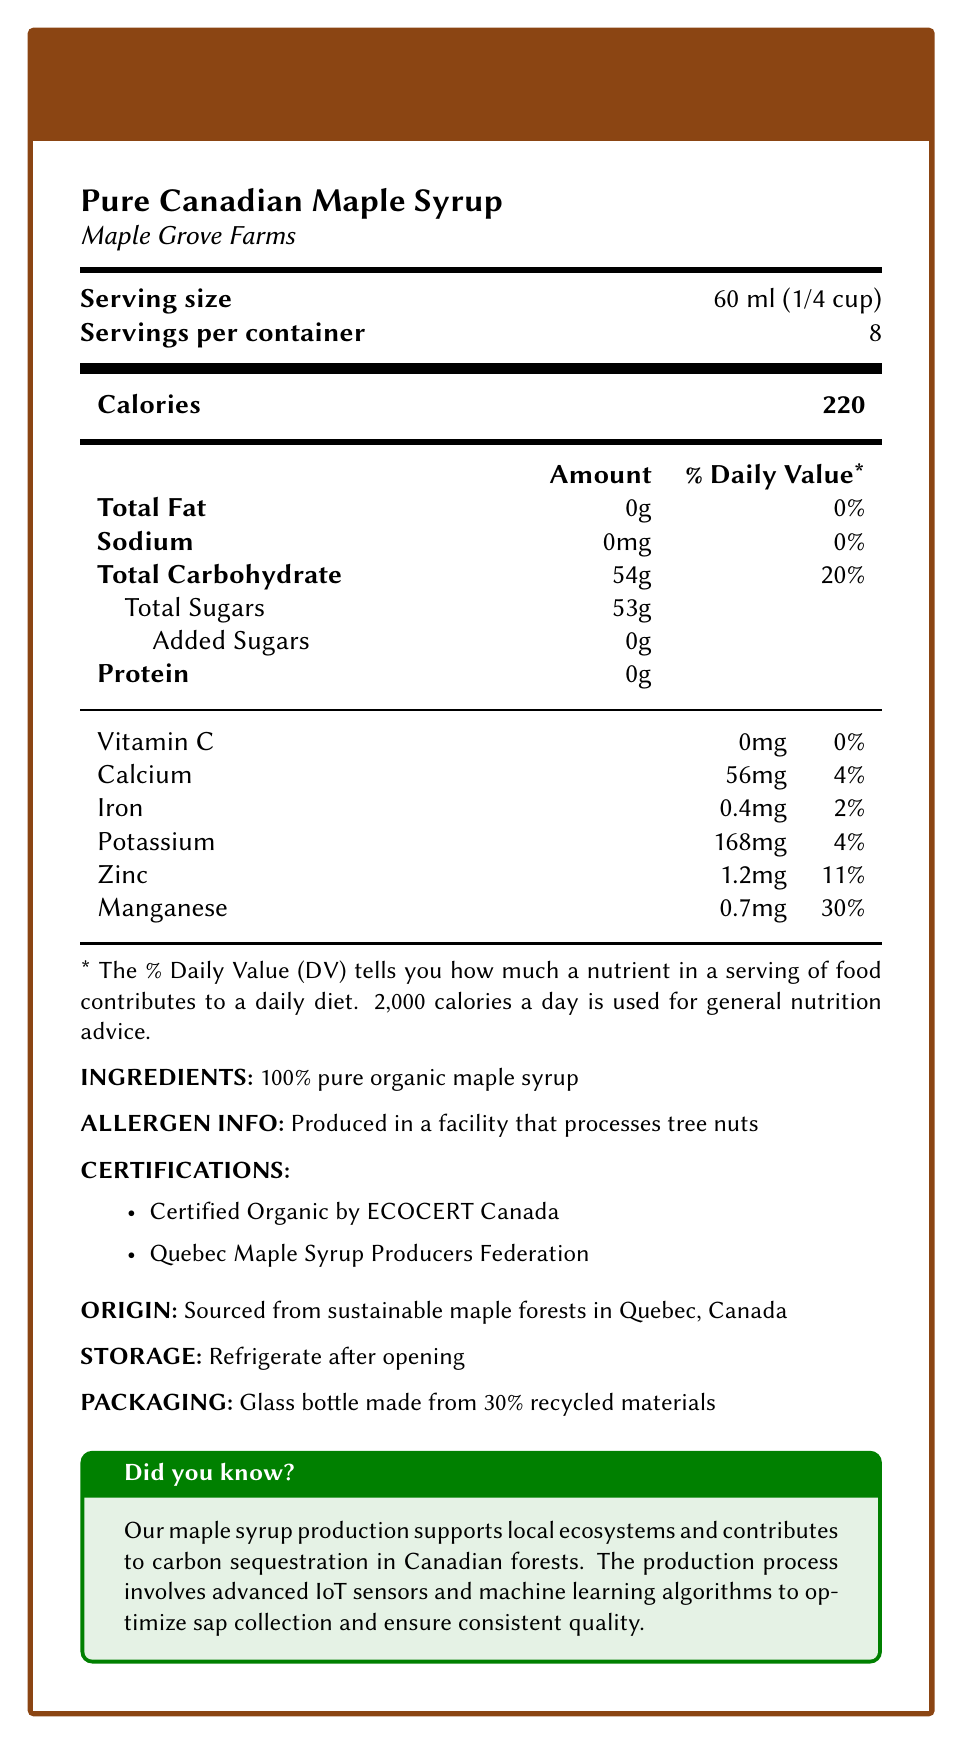what is the serving size of the Pure Canadian Maple Syrup? The serving size is specified directly under the product name and brand in the document.
Answer: 60 ml (1/4 cup) how many servings are in one container of the maple syrup? It is listed right below the serving size in the document.
Answer: 8 how many calories are in one serving of the maple syrup? The calorie content is specified in a separate section for calories, shown prominently.
Answer: 220 what percentage of the daily value of total carbohydrates does one serving of maple syrup provide? The daily value percentage for total carbohydrates is listed in the nutritional information table.
Answer: 20% does the maple syrup contain any total fat? The amount of total fat is listed as 0g, which corresponds to 0% of the daily value.
Answer: No what is the amount of potassium in one serving? The amount of potassium is listed in the detailed nutrient breakdown towards the bottom of the document.
Answer: 168mg what certifications does the maple syrup have? A. USDA Organic B. Certified Organic by ECOCERT Canada C. Fair Trade D. Quebec Maple Syrup Producers Federation The certifications section lists "Certified Organic by ECOCERT Canada" and "Quebec Maple Syrup Producers Federation".
Answer: B, D what are the main ingredients of the maple syrup? A. Maple syrup, water, sugar B. Pure maple syrup, sugar C. 100% pure organic maple syrup D. Tree nuts, maple syrup The ingredients section states "100% pure organic maple syrup".
Answer: C is the maple syrup produced in a facility that also processes tree nuts? The allergen information states that the syrup is produced in a facility that processes tree nuts.
Answer: Yes does the maple syrup contain added sugars? A. Yes B. No The document specifies that there are 0g of added sugars in the total sugars section.
Answer: B how does the production process for this maple syrup optimize sap collection? The additional info section details the use of advanced IoT sensors and machine learning algorithms for optimizing sap collection.
Answer: It involves advanced IoT sensors and machine learning algorithms. can you determine the expiration date of the maple syrup from the document? The document does not provide any information regarding the expiration date of the maple syrup.
Answer: Cannot be determined summarize the main details provided in the nutrition facts label of the Pure Canadian Maple Syrup. This summary captures the core details of the nutritional content, certifications, production process, and other notable aspects discussed in the nutrition facts document.
Answer: The nutrition facts label provides information about the serving size, servings per container, calories, and a detailed breakdown of nutrients. It indicates that the syrup contains 0g total fat, 54g total carbohydrates (with 53g total sugars and 0g added sugars), and 0g protein per serving. The label also includes percentages for daily values of certain vitamins and minerals and specifies that the only ingredient is 100% pure organic maple syrup. The product has certifications from ECOCERT Canada and the Quebec Maple Syrup Producers Federation, and it is produced in Quebec from sustainable maple forests. Additionally, it mentions allergen information, storage instructions, and packaging details. The document highlights the use of advanced technology in the production process and emphasizes the product’s contribution to sustainability. 